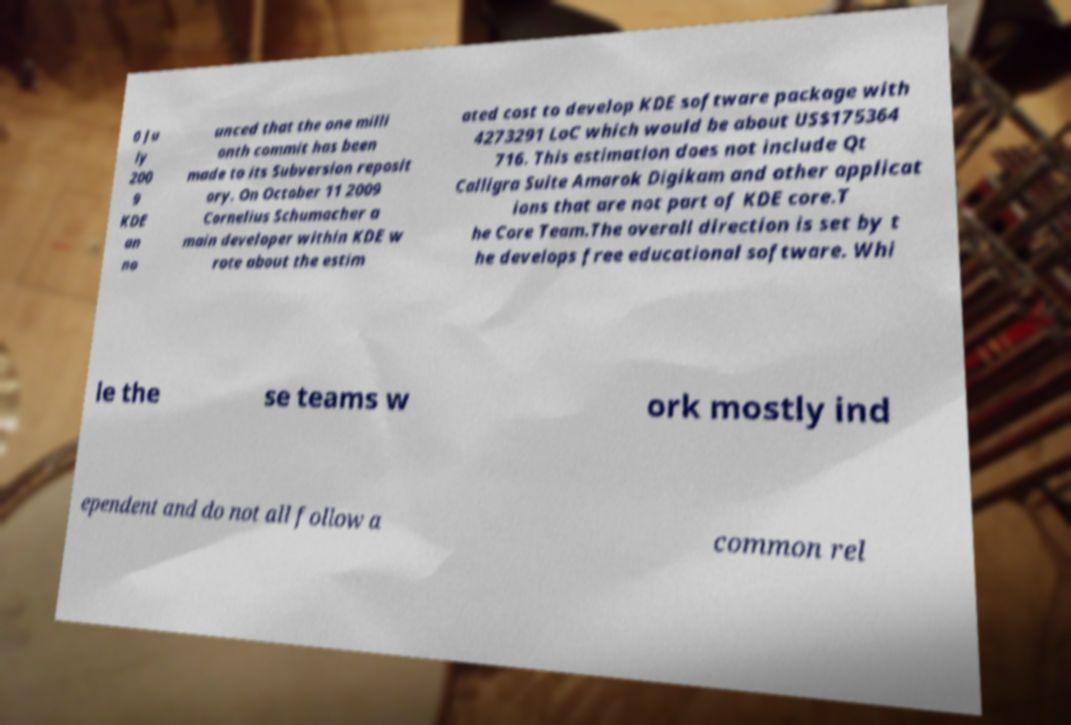What messages or text are displayed in this image? I need them in a readable, typed format. 0 Ju ly 200 9 KDE an no unced that the one milli onth commit has been made to its Subversion reposit ory. On October 11 2009 Cornelius Schumacher a main developer within KDE w rote about the estim ated cost to develop KDE software package with 4273291 LoC which would be about US$175364 716. This estimation does not include Qt Calligra Suite Amarok Digikam and other applicat ions that are not part of KDE core.T he Core Team.The overall direction is set by t he develops free educational software. Whi le the se teams w ork mostly ind ependent and do not all follow a common rel 